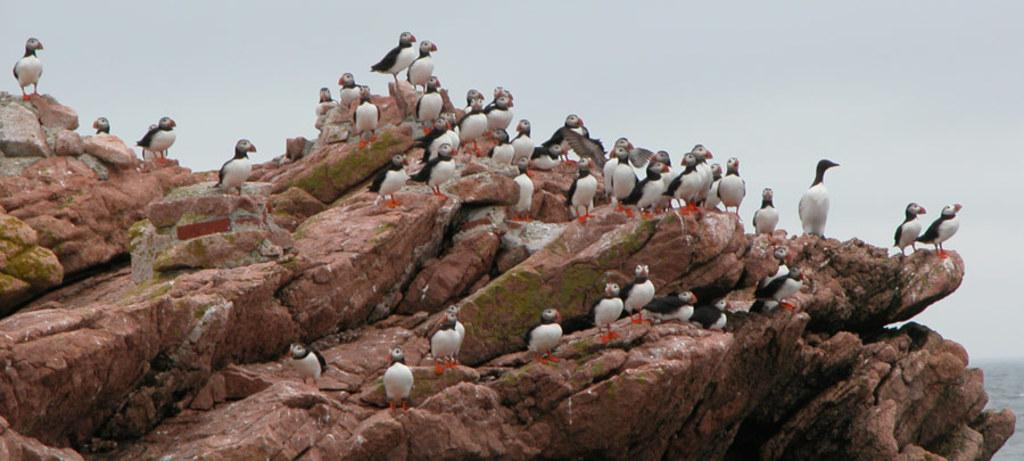What geographical feature is present in the image? There is a hill in the image. What can be seen on the hill? There is a group of birds on the hill. What is visible at the top of the hill? The sky is visible at the top of the hill. Who is the authority figure in charge of the birds on the hill? There is no authority figure mentioned or depicted in the image; it simply shows a group of birds on a hill. 